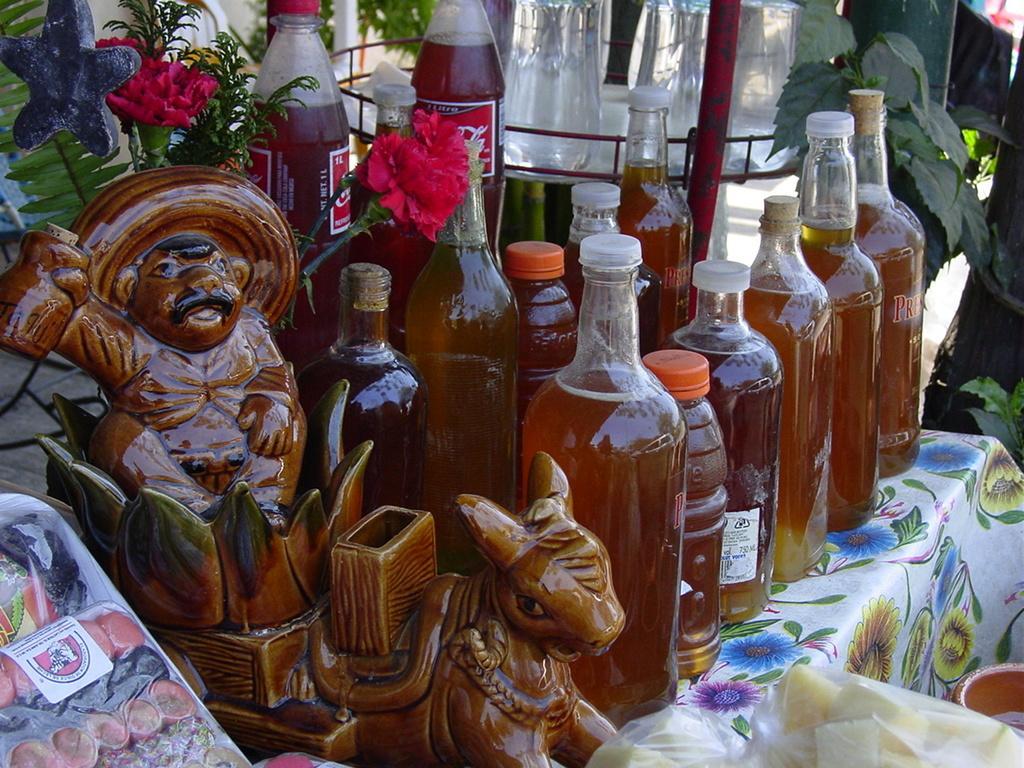Could you give a brief overview of what you see in this image? there are glass bottles on a table. at the left there is a sculpture and a food item. at the back there are flowers and plants at the right. 